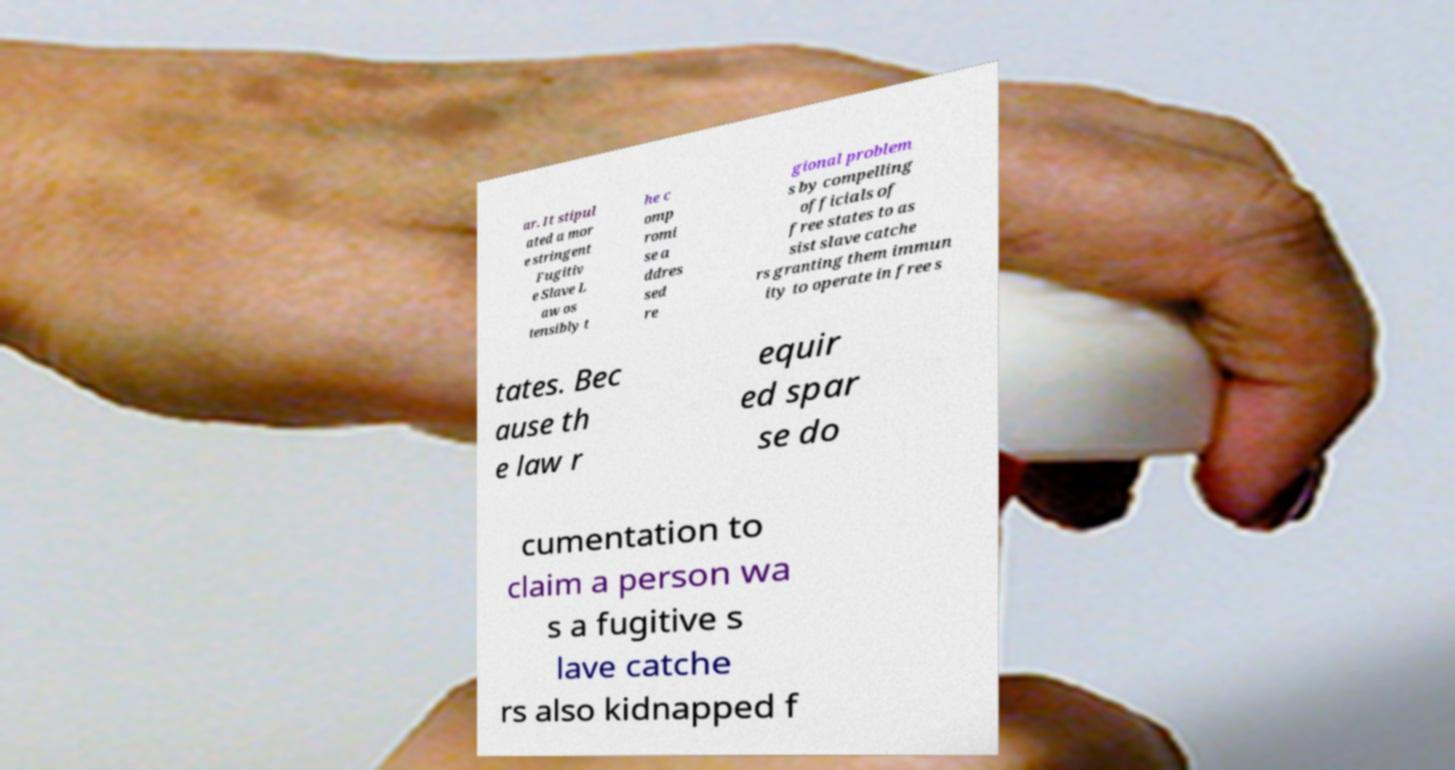There's text embedded in this image that I need extracted. Can you transcribe it verbatim? ar. It stipul ated a mor e stringent Fugitiv e Slave L aw os tensibly t he c omp romi se a ddres sed re gional problem s by compelling officials of free states to as sist slave catche rs granting them immun ity to operate in free s tates. Bec ause th e law r equir ed spar se do cumentation to claim a person wa s a fugitive s lave catche rs also kidnapped f 